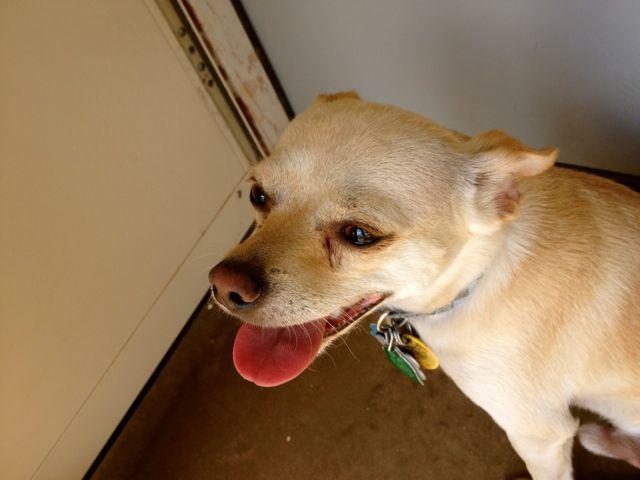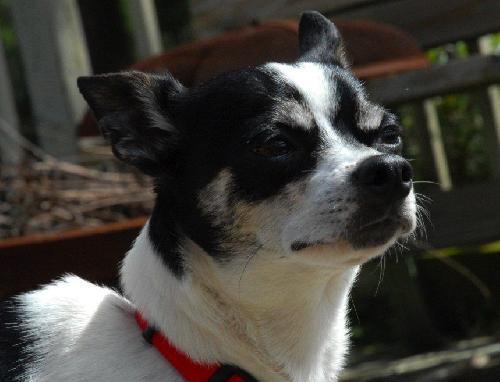The first image is the image on the left, the second image is the image on the right. For the images displayed, is the sentence "The right image contains a black and white chihuahua that is wearing a red collar." factually correct? Answer yes or no. Yes. The first image is the image on the left, the second image is the image on the right. For the images displayed, is the sentence "Each image contains exactly one dog, and the right image features a black-and-white dog wearing a red collar." factually correct? Answer yes or no. Yes. 